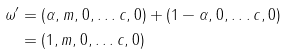Convert formula to latex. <formula><loc_0><loc_0><loc_500><loc_500>\omega ^ { \prime } & = ( \alpha , m , 0 , \dots c , 0 ) + ( 1 - \alpha , 0 , \dots c , 0 ) \\ & = ( 1 , m , 0 , \dots c , 0 )</formula> 